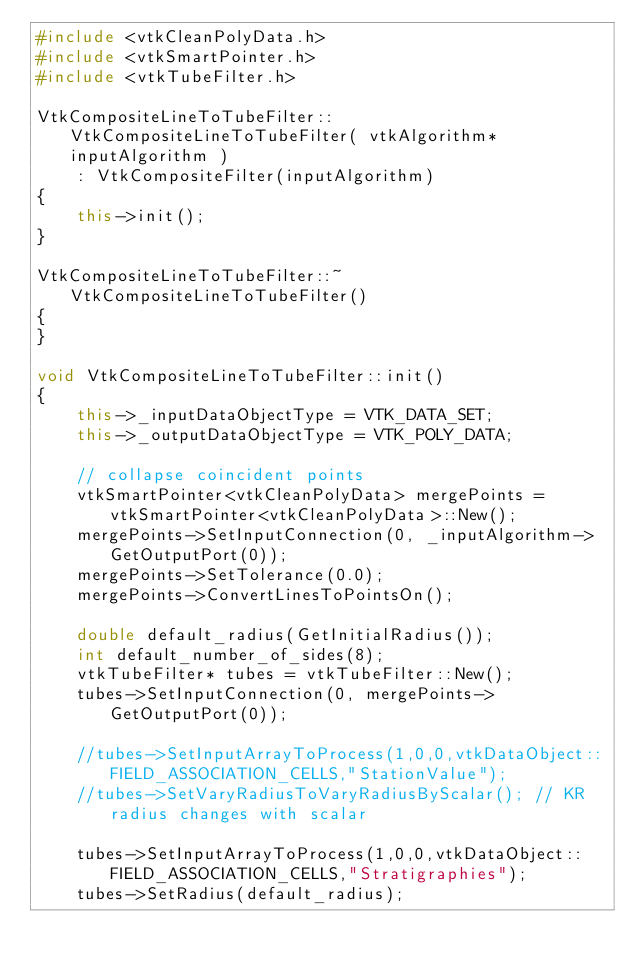<code> <loc_0><loc_0><loc_500><loc_500><_C++_>#include <vtkCleanPolyData.h>
#include <vtkSmartPointer.h>
#include <vtkTubeFilter.h>

VtkCompositeLineToTubeFilter::VtkCompositeLineToTubeFilter( vtkAlgorithm* inputAlgorithm )
    : VtkCompositeFilter(inputAlgorithm)
{
    this->init();
}

VtkCompositeLineToTubeFilter::~VtkCompositeLineToTubeFilter()
{
}

void VtkCompositeLineToTubeFilter::init()
{
    this->_inputDataObjectType = VTK_DATA_SET;
    this->_outputDataObjectType = VTK_POLY_DATA;

    // collapse coincident points
    vtkSmartPointer<vtkCleanPolyData> mergePoints = vtkSmartPointer<vtkCleanPolyData>::New();
    mergePoints->SetInputConnection(0, _inputAlgorithm->GetOutputPort(0));
    mergePoints->SetTolerance(0.0);
    mergePoints->ConvertLinesToPointsOn();

    double default_radius(GetInitialRadius());
    int default_number_of_sides(8);
    vtkTubeFilter* tubes = vtkTubeFilter::New();
    tubes->SetInputConnection(0, mergePoints->GetOutputPort(0));

    //tubes->SetInputArrayToProcess(1,0,0,vtkDataObject::FIELD_ASSOCIATION_CELLS,"StationValue");
    //tubes->SetVaryRadiusToVaryRadiusByScalar(); // KR radius changes with scalar

    tubes->SetInputArrayToProcess(1,0,0,vtkDataObject::FIELD_ASSOCIATION_CELLS,"Stratigraphies");
    tubes->SetRadius(default_radius);</code> 